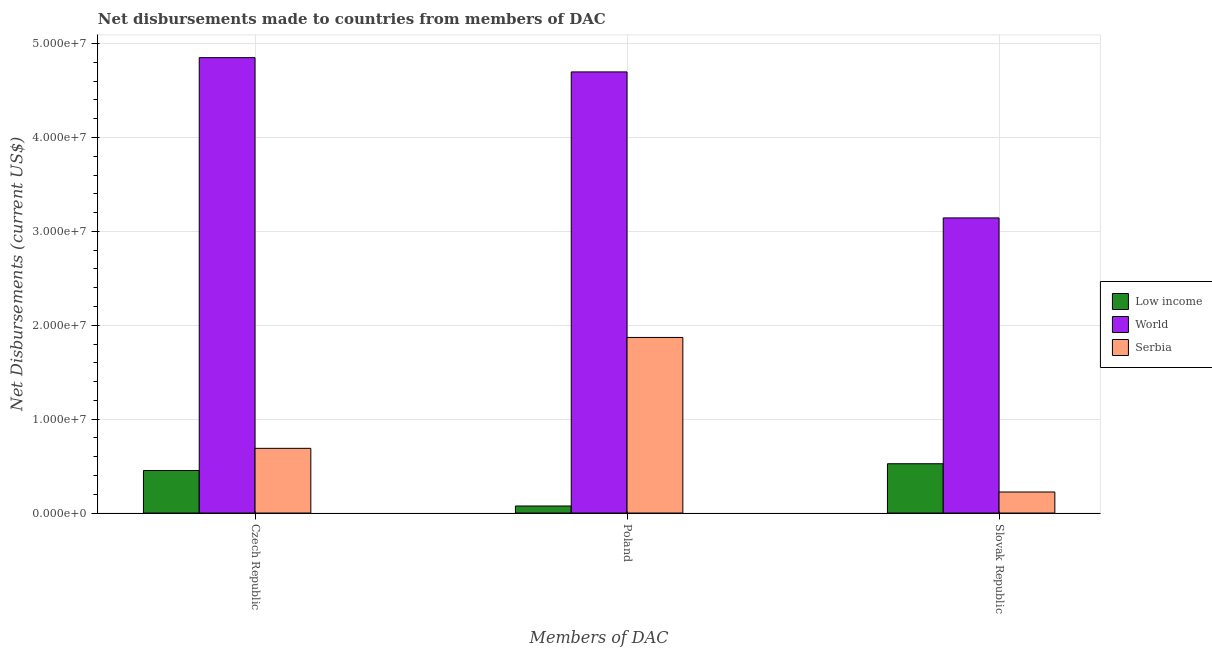Are the number of bars per tick equal to the number of legend labels?
Make the answer very short. Yes. How many bars are there on the 1st tick from the left?
Provide a succinct answer. 3. How many bars are there on the 2nd tick from the right?
Keep it short and to the point. 3. What is the label of the 3rd group of bars from the left?
Your response must be concise. Slovak Republic. What is the net disbursements made by czech republic in Low income?
Your answer should be very brief. 4.53e+06. Across all countries, what is the maximum net disbursements made by slovak republic?
Your response must be concise. 3.14e+07. Across all countries, what is the minimum net disbursements made by slovak republic?
Your response must be concise. 2.24e+06. In which country was the net disbursements made by slovak republic maximum?
Keep it short and to the point. World. In which country was the net disbursements made by slovak republic minimum?
Provide a short and direct response. Serbia. What is the total net disbursements made by poland in the graph?
Provide a short and direct response. 6.64e+07. What is the difference between the net disbursements made by poland in Serbia and that in World?
Offer a very short reply. -2.83e+07. What is the difference between the net disbursements made by poland in Serbia and the net disbursements made by czech republic in World?
Offer a terse response. -2.98e+07. What is the average net disbursements made by slovak republic per country?
Give a very brief answer. 1.30e+07. What is the difference between the net disbursements made by poland and net disbursements made by slovak republic in Serbia?
Give a very brief answer. 1.65e+07. In how many countries, is the net disbursements made by poland greater than 36000000 US$?
Provide a short and direct response. 1. What is the ratio of the net disbursements made by czech republic in Low income to that in Serbia?
Offer a very short reply. 0.66. Is the difference between the net disbursements made by slovak republic in Serbia and World greater than the difference between the net disbursements made by czech republic in Serbia and World?
Your answer should be very brief. Yes. What is the difference between the highest and the second highest net disbursements made by czech republic?
Your answer should be very brief. 4.16e+07. What is the difference between the highest and the lowest net disbursements made by czech republic?
Your answer should be very brief. 4.40e+07. What does the 2nd bar from the left in Poland represents?
Your response must be concise. World. What does the 1st bar from the right in Slovak Republic represents?
Your answer should be compact. Serbia. Is it the case that in every country, the sum of the net disbursements made by czech republic and net disbursements made by poland is greater than the net disbursements made by slovak republic?
Provide a succinct answer. Yes. Are all the bars in the graph horizontal?
Your response must be concise. No. How many countries are there in the graph?
Provide a succinct answer. 3. Does the graph contain any zero values?
Keep it short and to the point. No. Does the graph contain grids?
Ensure brevity in your answer.  Yes. Where does the legend appear in the graph?
Make the answer very short. Center right. What is the title of the graph?
Provide a short and direct response. Net disbursements made to countries from members of DAC. Does "Jordan" appear as one of the legend labels in the graph?
Your answer should be compact. No. What is the label or title of the X-axis?
Give a very brief answer. Members of DAC. What is the label or title of the Y-axis?
Provide a short and direct response. Net Disbursements (current US$). What is the Net Disbursements (current US$) of Low income in Czech Republic?
Make the answer very short. 4.53e+06. What is the Net Disbursements (current US$) of World in Czech Republic?
Provide a succinct answer. 4.85e+07. What is the Net Disbursements (current US$) of Serbia in Czech Republic?
Make the answer very short. 6.89e+06. What is the Net Disbursements (current US$) in Low income in Poland?
Make the answer very short. 7.50e+05. What is the Net Disbursements (current US$) in World in Poland?
Give a very brief answer. 4.70e+07. What is the Net Disbursements (current US$) of Serbia in Poland?
Give a very brief answer. 1.87e+07. What is the Net Disbursements (current US$) of Low income in Slovak Republic?
Your answer should be compact. 5.25e+06. What is the Net Disbursements (current US$) of World in Slovak Republic?
Ensure brevity in your answer.  3.14e+07. What is the Net Disbursements (current US$) in Serbia in Slovak Republic?
Make the answer very short. 2.24e+06. Across all Members of DAC, what is the maximum Net Disbursements (current US$) of Low income?
Provide a succinct answer. 5.25e+06. Across all Members of DAC, what is the maximum Net Disbursements (current US$) of World?
Your response must be concise. 4.85e+07. Across all Members of DAC, what is the maximum Net Disbursements (current US$) of Serbia?
Your response must be concise. 1.87e+07. Across all Members of DAC, what is the minimum Net Disbursements (current US$) in Low income?
Keep it short and to the point. 7.50e+05. Across all Members of DAC, what is the minimum Net Disbursements (current US$) of World?
Your response must be concise. 3.14e+07. Across all Members of DAC, what is the minimum Net Disbursements (current US$) in Serbia?
Offer a terse response. 2.24e+06. What is the total Net Disbursements (current US$) of Low income in the graph?
Provide a succinct answer. 1.05e+07. What is the total Net Disbursements (current US$) of World in the graph?
Keep it short and to the point. 1.27e+08. What is the total Net Disbursements (current US$) in Serbia in the graph?
Offer a terse response. 2.78e+07. What is the difference between the Net Disbursements (current US$) of Low income in Czech Republic and that in Poland?
Keep it short and to the point. 3.78e+06. What is the difference between the Net Disbursements (current US$) of World in Czech Republic and that in Poland?
Offer a terse response. 1.52e+06. What is the difference between the Net Disbursements (current US$) in Serbia in Czech Republic and that in Poland?
Offer a very short reply. -1.18e+07. What is the difference between the Net Disbursements (current US$) in Low income in Czech Republic and that in Slovak Republic?
Your answer should be compact. -7.20e+05. What is the difference between the Net Disbursements (current US$) of World in Czech Republic and that in Slovak Republic?
Your answer should be very brief. 1.71e+07. What is the difference between the Net Disbursements (current US$) in Serbia in Czech Republic and that in Slovak Republic?
Provide a succinct answer. 4.65e+06. What is the difference between the Net Disbursements (current US$) in Low income in Poland and that in Slovak Republic?
Keep it short and to the point. -4.50e+06. What is the difference between the Net Disbursements (current US$) in World in Poland and that in Slovak Republic?
Provide a short and direct response. 1.56e+07. What is the difference between the Net Disbursements (current US$) of Serbia in Poland and that in Slovak Republic?
Your answer should be compact. 1.65e+07. What is the difference between the Net Disbursements (current US$) of Low income in Czech Republic and the Net Disbursements (current US$) of World in Poland?
Your response must be concise. -4.24e+07. What is the difference between the Net Disbursements (current US$) of Low income in Czech Republic and the Net Disbursements (current US$) of Serbia in Poland?
Offer a very short reply. -1.42e+07. What is the difference between the Net Disbursements (current US$) in World in Czech Republic and the Net Disbursements (current US$) in Serbia in Poland?
Your response must be concise. 2.98e+07. What is the difference between the Net Disbursements (current US$) of Low income in Czech Republic and the Net Disbursements (current US$) of World in Slovak Republic?
Your response must be concise. -2.69e+07. What is the difference between the Net Disbursements (current US$) of Low income in Czech Republic and the Net Disbursements (current US$) of Serbia in Slovak Republic?
Offer a terse response. 2.29e+06. What is the difference between the Net Disbursements (current US$) of World in Czech Republic and the Net Disbursements (current US$) of Serbia in Slovak Republic?
Make the answer very short. 4.63e+07. What is the difference between the Net Disbursements (current US$) of Low income in Poland and the Net Disbursements (current US$) of World in Slovak Republic?
Ensure brevity in your answer.  -3.07e+07. What is the difference between the Net Disbursements (current US$) in Low income in Poland and the Net Disbursements (current US$) in Serbia in Slovak Republic?
Your response must be concise. -1.49e+06. What is the difference between the Net Disbursements (current US$) of World in Poland and the Net Disbursements (current US$) of Serbia in Slovak Republic?
Keep it short and to the point. 4.47e+07. What is the average Net Disbursements (current US$) in Low income per Members of DAC?
Keep it short and to the point. 3.51e+06. What is the average Net Disbursements (current US$) of World per Members of DAC?
Offer a very short reply. 4.23e+07. What is the average Net Disbursements (current US$) of Serbia per Members of DAC?
Your answer should be very brief. 9.28e+06. What is the difference between the Net Disbursements (current US$) of Low income and Net Disbursements (current US$) of World in Czech Republic?
Your answer should be compact. -4.40e+07. What is the difference between the Net Disbursements (current US$) of Low income and Net Disbursements (current US$) of Serbia in Czech Republic?
Your response must be concise. -2.36e+06. What is the difference between the Net Disbursements (current US$) of World and Net Disbursements (current US$) of Serbia in Czech Republic?
Provide a succinct answer. 4.16e+07. What is the difference between the Net Disbursements (current US$) of Low income and Net Disbursements (current US$) of World in Poland?
Provide a succinct answer. -4.62e+07. What is the difference between the Net Disbursements (current US$) of Low income and Net Disbursements (current US$) of Serbia in Poland?
Offer a terse response. -1.80e+07. What is the difference between the Net Disbursements (current US$) of World and Net Disbursements (current US$) of Serbia in Poland?
Your answer should be very brief. 2.83e+07. What is the difference between the Net Disbursements (current US$) of Low income and Net Disbursements (current US$) of World in Slovak Republic?
Ensure brevity in your answer.  -2.62e+07. What is the difference between the Net Disbursements (current US$) of Low income and Net Disbursements (current US$) of Serbia in Slovak Republic?
Offer a terse response. 3.01e+06. What is the difference between the Net Disbursements (current US$) of World and Net Disbursements (current US$) of Serbia in Slovak Republic?
Your response must be concise. 2.92e+07. What is the ratio of the Net Disbursements (current US$) of Low income in Czech Republic to that in Poland?
Offer a terse response. 6.04. What is the ratio of the Net Disbursements (current US$) in World in Czech Republic to that in Poland?
Make the answer very short. 1.03. What is the ratio of the Net Disbursements (current US$) in Serbia in Czech Republic to that in Poland?
Offer a terse response. 0.37. What is the ratio of the Net Disbursements (current US$) of Low income in Czech Republic to that in Slovak Republic?
Your answer should be compact. 0.86. What is the ratio of the Net Disbursements (current US$) of World in Czech Republic to that in Slovak Republic?
Your answer should be very brief. 1.54. What is the ratio of the Net Disbursements (current US$) of Serbia in Czech Republic to that in Slovak Republic?
Make the answer very short. 3.08. What is the ratio of the Net Disbursements (current US$) of Low income in Poland to that in Slovak Republic?
Your response must be concise. 0.14. What is the ratio of the Net Disbursements (current US$) in World in Poland to that in Slovak Republic?
Ensure brevity in your answer.  1.49. What is the ratio of the Net Disbursements (current US$) in Serbia in Poland to that in Slovak Republic?
Offer a very short reply. 8.35. What is the difference between the highest and the second highest Net Disbursements (current US$) of Low income?
Ensure brevity in your answer.  7.20e+05. What is the difference between the highest and the second highest Net Disbursements (current US$) in World?
Keep it short and to the point. 1.52e+06. What is the difference between the highest and the second highest Net Disbursements (current US$) of Serbia?
Your answer should be very brief. 1.18e+07. What is the difference between the highest and the lowest Net Disbursements (current US$) in Low income?
Ensure brevity in your answer.  4.50e+06. What is the difference between the highest and the lowest Net Disbursements (current US$) in World?
Your answer should be very brief. 1.71e+07. What is the difference between the highest and the lowest Net Disbursements (current US$) in Serbia?
Ensure brevity in your answer.  1.65e+07. 